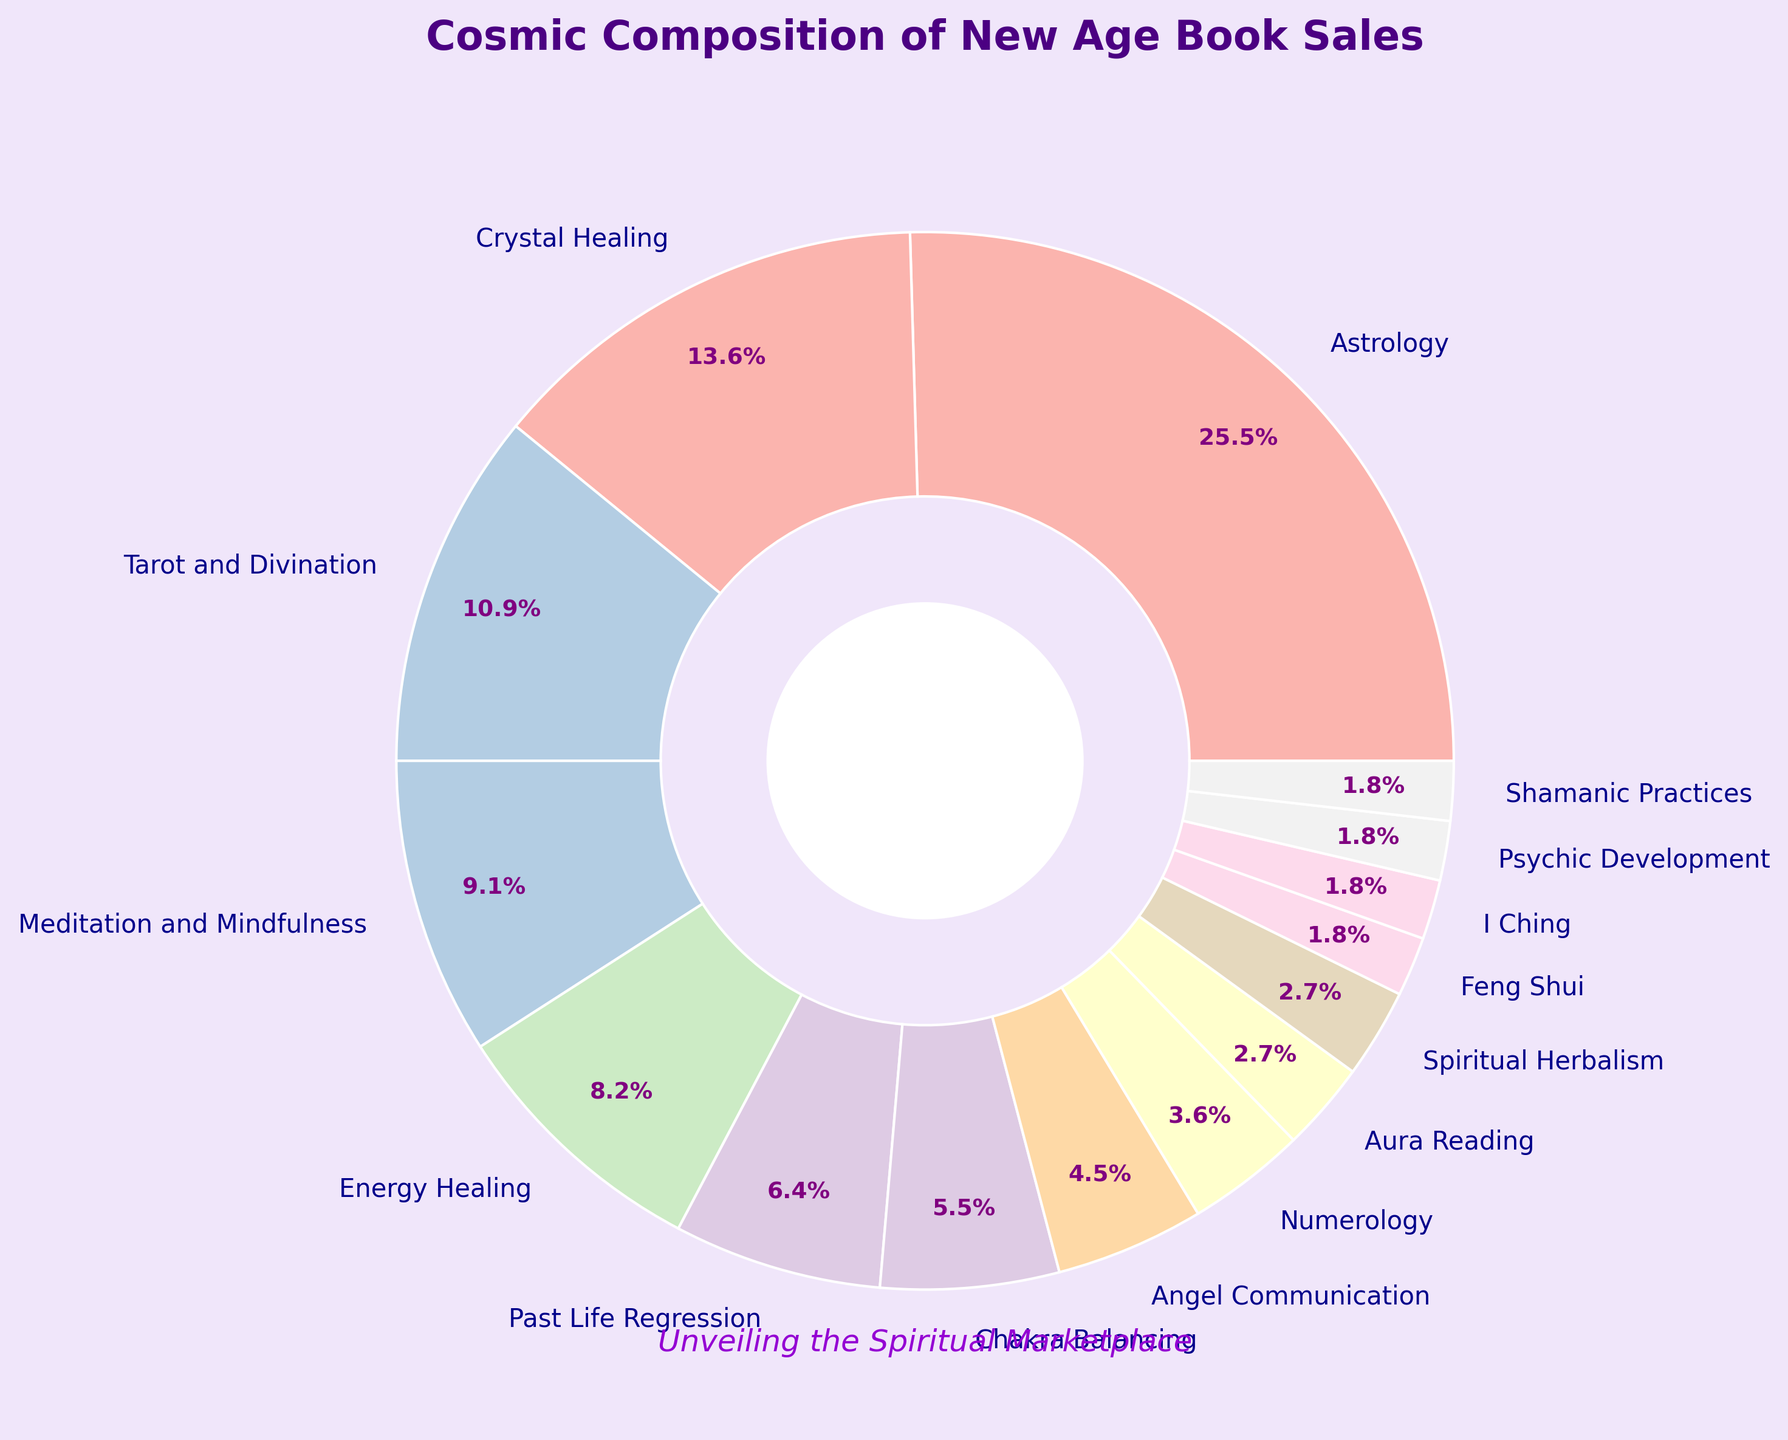What is the combined percentage of book sales for Astrology and Crystal Healing? To find the combined percentage, add the percentage for Astrology (28%) and Crystal Healing (15%). 28% + 15% = 43%.
Answer: 43% Which subject has the lowest percentage of book sales? To find the subject with the lowest percentage, look for the smallest value in the percentage list. The smallest value is 2%, which is shared by Feng Shui, I Ching, Psychic Development, and Shamanic Practices.
Answer: Feng Shui, I Ching, Psychic Development, Shamanic Practices Is the percentage of book sales for Meditation and Mindfulness higher or lower than the percentage for Energy Healing? The percentage for Meditation and Mindfulness is 10%, while the percentage for Energy Healing is 9%. 10% is higher than 9%.
Answer: Higher By how much do book sales for Tarot and Divination exceed those for Numerology? The percentage for Tarot and Divination is 12%, and for Numerology, it is 4%. Subtract the lower value from the higher value: 12% - 4% = 8%.
Answer: 8% What is the cumulative percentage for the categories making up 10% or more of book sales? Identify categories with 10% or more: Astrology (28%), Crystal Healing (15%), and Tarot and Divination (12%), and Meditation and Mindfulness (10%). Add these percentages: 28% + 15% + 12% + 10% = 65%.
Answer: 65% Which category, between Angel Communication and Chakra Balancing, has a higher percentage of book sales? The percentage for Angel Communication is 5%, and for Chakra Balancing, it is 6%. 6% is higher than 5%.
Answer: Chakra Balancing How do the total book sales percentages for Aura Reading and Spiritual Herbalism compare to those for Psychic Development and Shamanic Practices? Add the percentages: Aura Reading (3%) + Spiritual Herbalism (3%) = 6%, and Psychic Development (2%) + Shamanic Practices (2%) = 4%. 6% is greater than 4%.
Answer: Aura Reading and Spiritual Herbalism are higher What is the difference in the percentages between the highest and lowest book sales categories? The highest is Astrology (28%) and the lowest are Feng Shui, I Ching, Psychic Development, and Shamanic Practices (2%). Subtract the lowest from the highest: 28% - 2% = 26%.
Answer: 26% If you combine the book sales for Astrology, Crystal Healing, and Energy Healing, what fraction of the whole market do they represent? Add the percentages for Astrology (28%), Crystal Healing (15%), and Energy Healing (9%): 28% + 15% + 9% = 52%. Therefore, these subjects represent 52% of the whole market, which is 52/100 as a fraction.
Answer: 52/100 